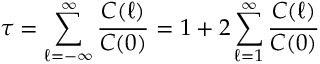<formula> <loc_0><loc_0><loc_500><loc_500>\tau = \sum _ { \ell = - \infty } ^ { \infty } \frac { C ( \ell ) } { C ( 0 ) } = 1 + 2 \sum _ { \ell = 1 } ^ { \infty } \frac { C ( \ell ) } { C ( 0 ) }</formula> 